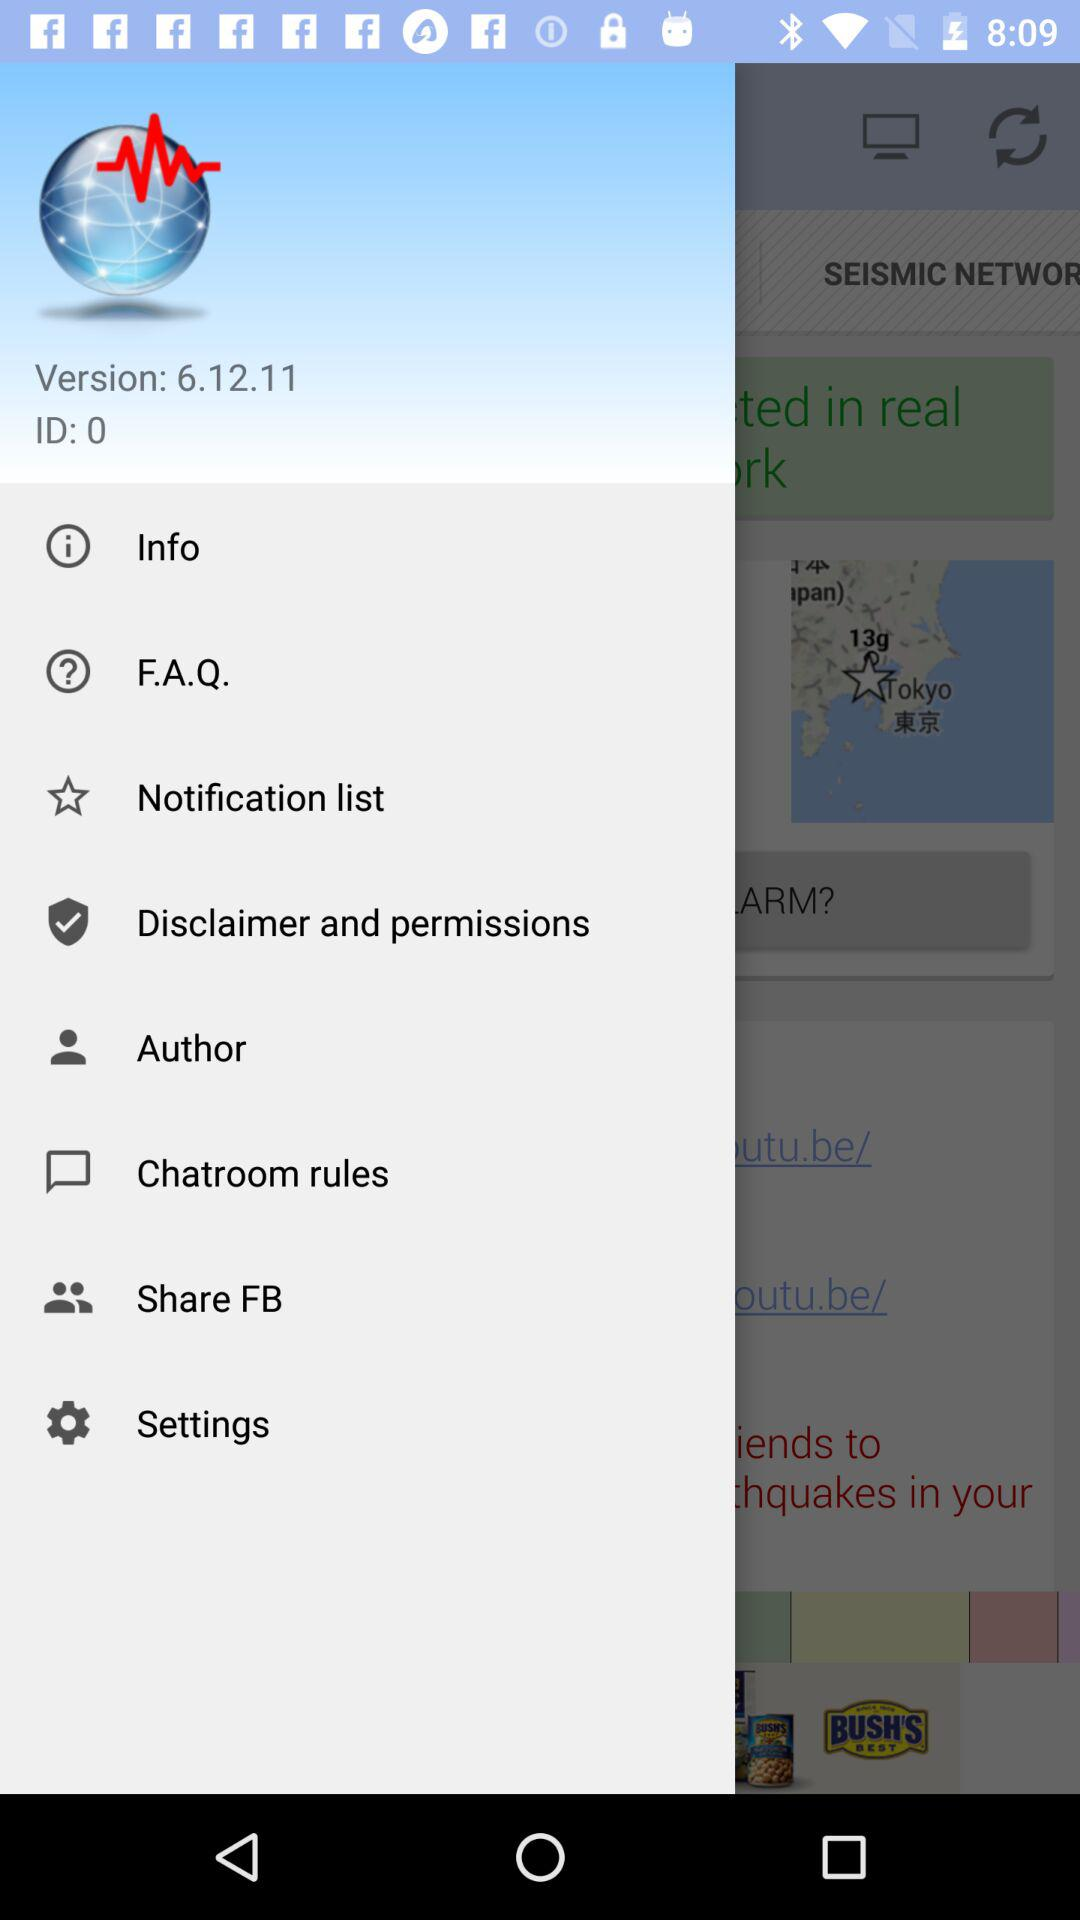What is the ID? The ID is 0. 